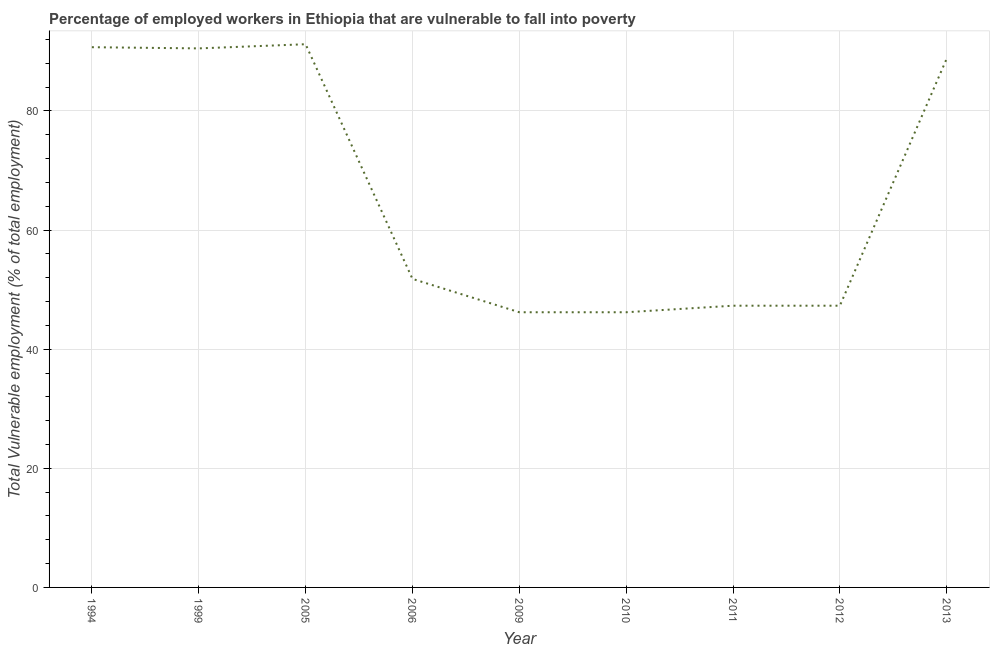What is the total vulnerable employment in 2012?
Offer a very short reply. 47.3. Across all years, what is the maximum total vulnerable employment?
Offer a terse response. 91.2. Across all years, what is the minimum total vulnerable employment?
Provide a succinct answer. 46.2. In which year was the total vulnerable employment maximum?
Give a very brief answer. 2005. What is the sum of the total vulnerable employment?
Ensure brevity in your answer.  600. What is the difference between the total vulnerable employment in 1999 and 2006?
Make the answer very short. 38.7. What is the average total vulnerable employment per year?
Give a very brief answer. 66.67. What is the median total vulnerable employment?
Keep it short and to the point. 51.8. In how many years, is the total vulnerable employment greater than 52 %?
Make the answer very short. 4. Do a majority of the years between 2013 and 1999 (inclusive) have total vulnerable employment greater than 36 %?
Keep it short and to the point. Yes. What is the ratio of the total vulnerable employment in 1999 to that in 2013?
Provide a short and direct response. 1.02. Is the total vulnerable employment in 2009 less than that in 2011?
Provide a succinct answer. Yes. Is the difference between the total vulnerable employment in 2005 and 2009 greater than the difference between any two years?
Keep it short and to the point. Yes. What is the difference between the highest and the second highest total vulnerable employment?
Provide a short and direct response. 0.5. What is the difference between the highest and the lowest total vulnerable employment?
Provide a short and direct response. 45. In how many years, is the total vulnerable employment greater than the average total vulnerable employment taken over all years?
Your answer should be very brief. 4. What is the title of the graph?
Make the answer very short. Percentage of employed workers in Ethiopia that are vulnerable to fall into poverty. What is the label or title of the Y-axis?
Your answer should be compact. Total Vulnerable employment (% of total employment). What is the Total Vulnerable employment (% of total employment) of 1994?
Give a very brief answer. 90.7. What is the Total Vulnerable employment (% of total employment) in 1999?
Give a very brief answer. 90.5. What is the Total Vulnerable employment (% of total employment) of 2005?
Your answer should be very brief. 91.2. What is the Total Vulnerable employment (% of total employment) in 2006?
Provide a short and direct response. 51.8. What is the Total Vulnerable employment (% of total employment) of 2009?
Your answer should be compact. 46.2. What is the Total Vulnerable employment (% of total employment) of 2010?
Ensure brevity in your answer.  46.2. What is the Total Vulnerable employment (% of total employment) of 2011?
Your answer should be very brief. 47.3. What is the Total Vulnerable employment (% of total employment) of 2012?
Give a very brief answer. 47.3. What is the Total Vulnerable employment (% of total employment) in 2013?
Your answer should be compact. 88.8. What is the difference between the Total Vulnerable employment (% of total employment) in 1994 and 2005?
Make the answer very short. -0.5. What is the difference between the Total Vulnerable employment (% of total employment) in 1994 and 2006?
Offer a very short reply. 38.9. What is the difference between the Total Vulnerable employment (% of total employment) in 1994 and 2009?
Your answer should be compact. 44.5. What is the difference between the Total Vulnerable employment (% of total employment) in 1994 and 2010?
Your answer should be compact. 44.5. What is the difference between the Total Vulnerable employment (% of total employment) in 1994 and 2011?
Offer a terse response. 43.4. What is the difference between the Total Vulnerable employment (% of total employment) in 1994 and 2012?
Make the answer very short. 43.4. What is the difference between the Total Vulnerable employment (% of total employment) in 1994 and 2013?
Provide a short and direct response. 1.9. What is the difference between the Total Vulnerable employment (% of total employment) in 1999 and 2006?
Offer a terse response. 38.7. What is the difference between the Total Vulnerable employment (% of total employment) in 1999 and 2009?
Your response must be concise. 44.3. What is the difference between the Total Vulnerable employment (% of total employment) in 1999 and 2010?
Provide a short and direct response. 44.3. What is the difference between the Total Vulnerable employment (% of total employment) in 1999 and 2011?
Ensure brevity in your answer.  43.2. What is the difference between the Total Vulnerable employment (% of total employment) in 1999 and 2012?
Your answer should be compact. 43.2. What is the difference between the Total Vulnerable employment (% of total employment) in 1999 and 2013?
Offer a very short reply. 1.7. What is the difference between the Total Vulnerable employment (% of total employment) in 2005 and 2006?
Ensure brevity in your answer.  39.4. What is the difference between the Total Vulnerable employment (% of total employment) in 2005 and 2009?
Offer a terse response. 45. What is the difference between the Total Vulnerable employment (% of total employment) in 2005 and 2010?
Your response must be concise. 45. What is the difference between the Total Vulnerable employment (% of total employment) in 2005 and 2011?
Provide a short and direct response. 43.9. What is the difference between the Total Vulnerable employment (% of total employment) in 2005 and 2012?
Provide a short and direct response. 43.9. What is the difference between the Total Vulnerable employment (% of total employment) in 2005 and 2013?
Ensure brevity in your answer.  2.4. What is the difference between the Total Vulnerable employment (% of total employment) in 2006 and 2009?
Provide a succinct answer. 5.6. What is the difference between the Total Vulnerable employment (% of total employment) in 2006 and 2010?
Your answer should be very brief. 5.6. What is the difference between the Total Vulnerable employment (% of total employment) in 2006 and 2011?
Provide a short and direct response. 4.5. What is the difference between the Total Vulnerable employment (% of total employment) in 2006 and 2012?
Provide a succinct answer. 4.5. What is the difference between the Total Vulnerable employment (% of total employment) in 2006 and 2013?
Make the answer very short. -37. What is the difference between the Total Vulnerable employment (% of total employment) in 2009 and 2010?
Offer a very short reply. 0. What is the difference between the Total Vulnerable employment (% of total employment) in 2009 and 2013?
Make the answer very short. -42.6. What is the difference between the Total Vulnerable employment (% of total employment) in 2010 and 2013?
Offer a very short reply. -42.6. What is the difference between the Total Vulnerable employment (% of total employment) in 2011 and 2012?
Provide a short and direct response. 0. What is the difference between the Total Vulnerable employment (% of total employment) in 2011 and 2013?
Ensure brevity in your answer.  -41.5. What is the difference between the Total Vulnerable employment (% of total employment) in 2012 and 2013?
Ensure brevity in your answer.  -41.5. What is the ratio of the Total Vulnerable employment (% of total employment) in 1994 to that in 1999?
Your answer should be very brief. 1. What is the ratio of the Total Vulnerable employment (% of total employment) in 1994 to that in 2006?
Make the answer very short. 1.75. What is the ratio of the Total Vulnerable employment (% of total employment) in 1994 to that in 2009?
Ensure brevity in your answer.  1.96. What is the ratio of the Total Vulnerable employment (% of total employment) in 1994 to that in 2010?
Provide a short and direct response. 1.96. What is the ratio of the Total Vulnerable employment (% of total employment) in 1994 to that in 2011?
Give a very brief answer. 1.92. What is the ratio of the Total Vulnerable employment (% of total employment) in 1994 to that in 2012?
Your answer should be compact. 1.92. What is the ratio of the Total Vulnerable employment (% of total employment) in 1999 to that in 2006?
Your answer should be compact. 1.75. What is the ratio of the Total Vulnerable employment (% of total employment) in 1999 to that in 2009?
Ensure brevity in your answer.  1.96. What is the ratio of the Total Vulnerable employment (% of total employment) in 1999 to that in 2010?
Your response must be concise. 1.96. What is the ratio of the Total Vulnerable employment (% of total employment) in 1999 to that in 2011?
Offer a terse response. 1.91. What is the ratio of the Total Vulnerable employment (% of total employment) in 1999 to that in 2012?
Your response must be concise. 1.91. What is the ratio of the Total Vulnerable employment (% of total employment) in 2005 to that in 2006?
Give a very brief answer. 1.76. What is the ratio of the Total Vulnerable employment (% of total employment) in 2005 to that in 2009?
Give a very brief answer. 1.97. What is the ratio of the Total Vulnerable employment (% of total employment) in 2005 to that in 2010?
Give a very brief answer. 1.97. What is the ratio of the Total Vulnerable employment (% of total employment) in 2005 to that in 2011?
Your answer should be very brief. 1.93. What is the ratio of the Total Vulnerable employment (% of total employment) in 2005 to that in 2012?
Give a very brief answer. 1.93. What is the ratio of the Total Vulnerable employment (% of total employment) in 2005 to that in 2013?
Make the answer very short. 1.03. What is the ratio of the Total Vulnerable employment (% of total employment) in 2006 to that in 2009?
Provide a short and direct response. 1.12. What is the ratio of the Total Vulnerable employment (% of total employment) in 2006 to that in 2010?
Provide a short and direct response. 1.12. What is the ratio of the Total Vulnerable employment (% of total employment) in 2006 to that in 2011?
Provide a succinct answer. 1.09. What is the ratio of the Total Vulnerable employment (% of total employment) in 2006 to that in 2012?
Ensure brevity in your answer.  1.09. What is the ratio of the Total Vulnerable employment (% of total employment) in 2006 to that in 2013?
Your answer should be very brief. 0.58. What is the ratio of the Total Vulnerable employment (% of total employment) in 2009 to that in 2010?
Give a very brief answer. 1. What is the ratio of the Total Vulnerable employment (% of total employment) in 2009 to that in 2011?
Provide a short and direct response. 0.98. What is the ratio of the Total Vulnerable employment (% of total employment) in 2009 to that in 2012?
Keep it short and to the point. 0.98. What is the ratio of the Total Vulnerable employment (% of total employment) in 2009 to that in 2013?
Make the answer very short. 0.52. What is the ratio of the Total Vulnerable employment (% of total employment) in 2010 to that in 2011?
Ensure brevity in your answer.  0.98. What is the ratio of the Total Vulnerable employment (% of total employment) in 2010 to that in 2012?
Offer a very short reply. 0.98. What is the ratio of the Total Vulnerable employment (% of total employment) in 2010 to that in 2013?
Provide a succinct answer. 0.52. What is the ratio of the Total Vulnerable employment (% of total employment) in 2011 to that in 2013?
Offer a terse response. 0.53. What is the ratio of the Total Vulnerable employment (% of total employment) in 2012 to that in 2013?
Your answer should be compact. 0.53. 